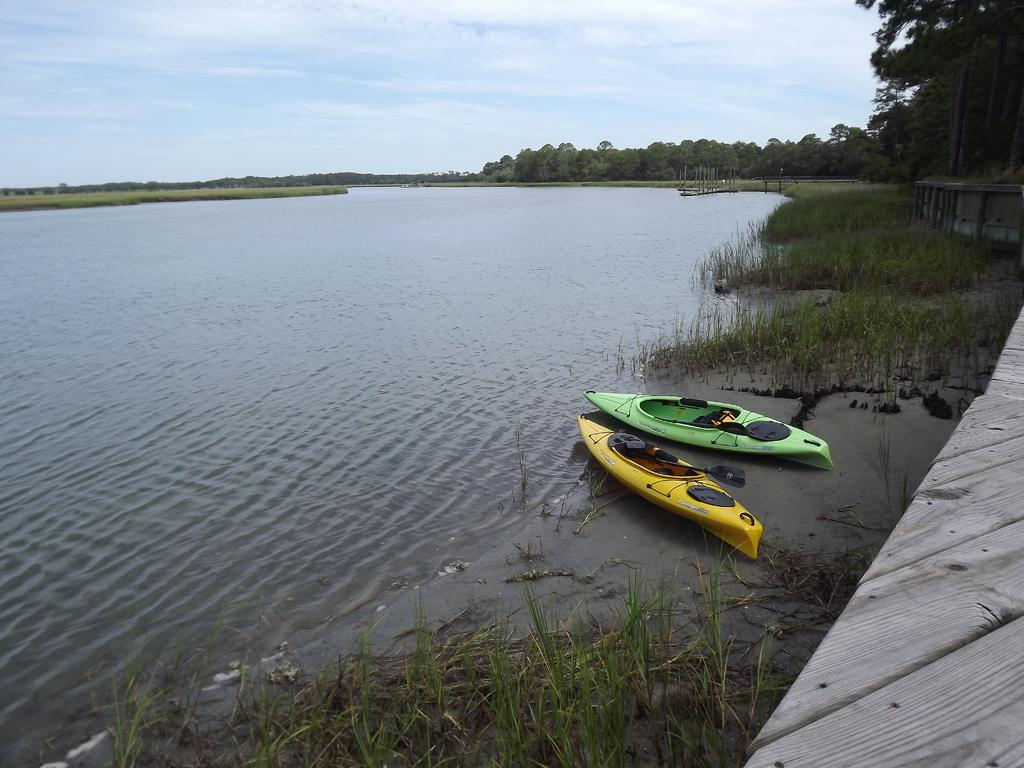How many boats are in the image? There are two boats in the image. What colors are the boats? One boat is yellow, and the other is green. What is the primary element in which the boats are situated? There is water in the image, and the boats are situated in it. What can be seen in the background of the image? There are trees and a clear sky in the background of the image. Where is the seed planted in the image? There is no seed present in the image. Can you tell me how many basketballs are visible in the image? There are no basketballs visible in the image. 